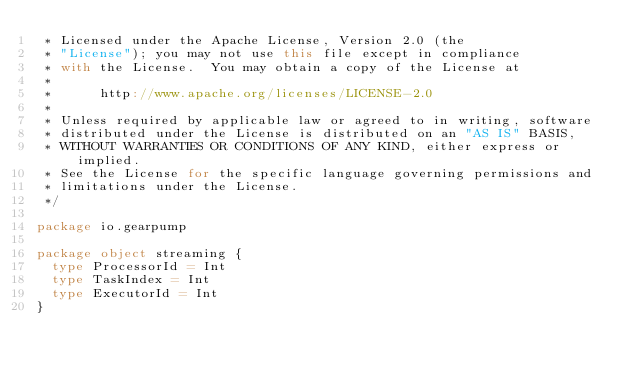Convert code to text. <code><loc_0><loc_0><loc_500><loc_500><_Scala_> * Licensed under the Apache License, Version 2.0 (the
 * "License"); you may not use this file except in compliance
 * with the License.  You may obtain a copy of the License at
 *
 *      http://www.apache.org/licenses/LICENSE-2.0
 *
 * Unless required by applicable law or agreed to in writing, software
 * distributed under the License is distributed on an "AS IS" BASIS,
 * WITHOUT WARRANTIES OR CONDITIONS OF ANY KIND, either express or implied.
 * See the License for the specific language governing permissions and
 * limitations under the License.
 */

package io.gearpump

package object streaming {
  type ProcessorId = Int
  type TaskIndex = Int
  type ExecutorId = Int
}
</code> 